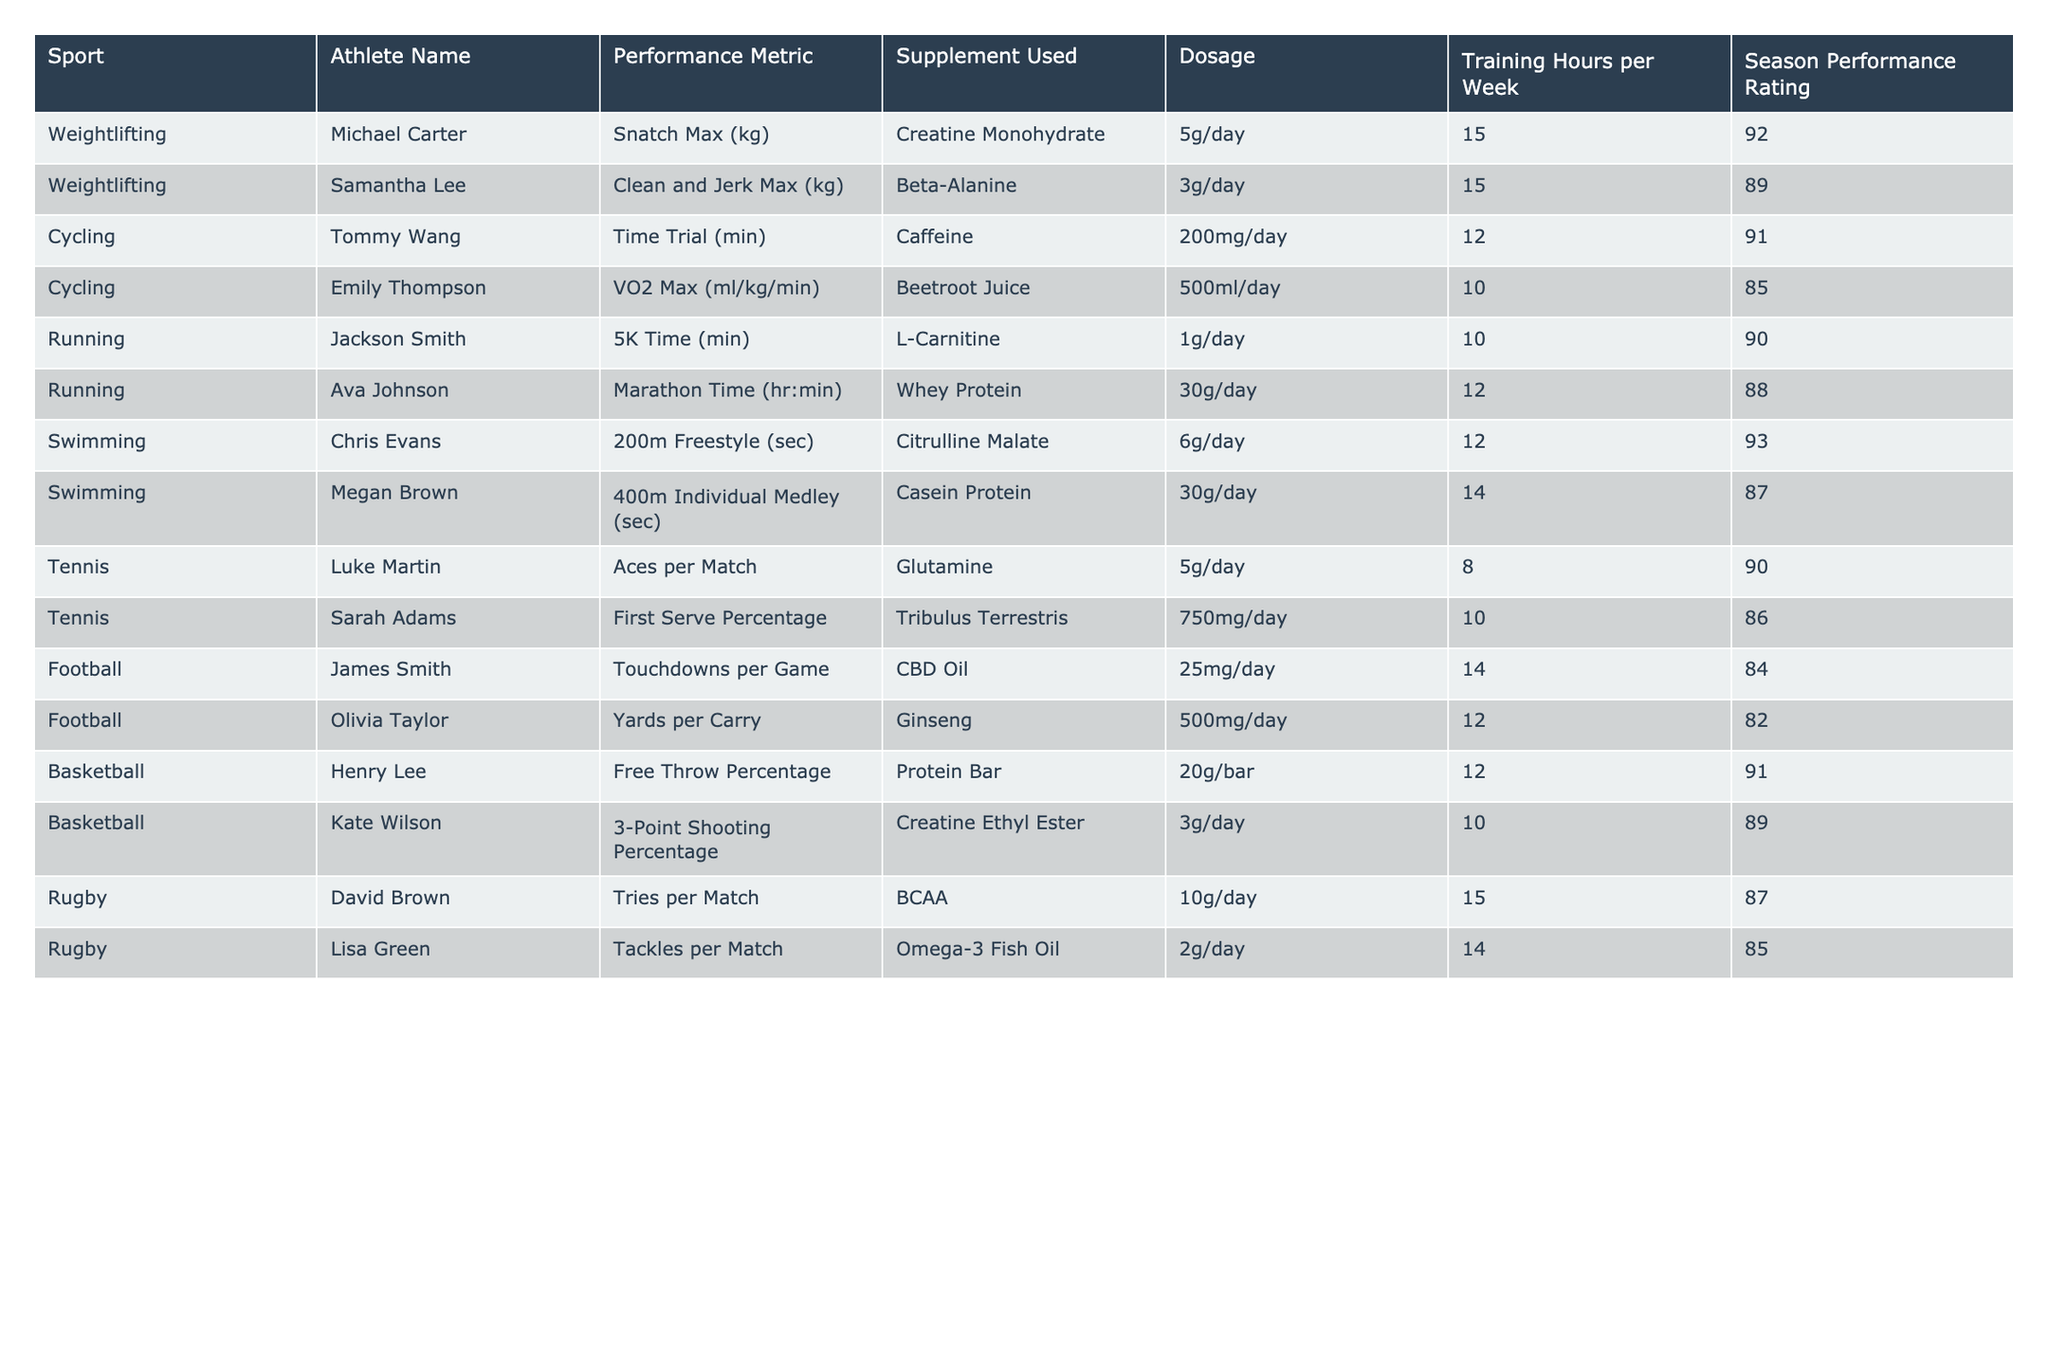What is the performance metric for Sarah Adams? According to the table, Sarah Adams has a performance metric of First Serve Percentage in Tennis.
Answer: First Serve Percentage Which athlete has the highest Season Performance Rating? By reviewing the Season Performance Ratings, Chris Evans has the highest rating of 93 in Swimming.
Answer: 93 What supplement is used by Jackson Smith? The table indicates that Jackson Smith uses L-Carnitine as his supplement.
Answer: L-Carnitine What is the average Training Hours per Week for athletes who use Creatine? The athletes using Creatine are Michael Carter (15 hours) and Kate Wilson (10 hours). Their total training hours sum to 25 hours, and with 2 athletes, the average is 25/2 = 12.5 hours.
Answer: 12.5 Is there an athlete who uses Omega-3 Fish Oil and has a performance rating above 85? Lisa Green uses Omega-3 Fish Oil and has a performance rating of 85, which is not above 85, so the answer is no.
Answer: No What is the difference in performance metric values between Samantha Lee and Ava Johnson? Samantha Lee's performance metric for Clean and Jerk Max is 89, while Ava Johnson's Marathon Time rating is 88. The difference is 89 - 88 = 1.
Answer: 1 Do all athletes who use protein supplements have a Season Performance Rating above 85? The athletes using protein supplements are Ava Johnson (88) and Megan Brown (87), both above 85. Thus, all athletes using protein supplements have ratings above 85.
Answer: Yes Which sport has the most athletes listed in the table and what are their names? Reviewing the table, Rugby has two athletes listed: David Brown and Lisa Green, while all other sports have one athlete each.
Answer: Rugby: David Brown, Lisa Green What is the correlation between dosage and performance rating for the cyclists? For cyclists, Tommy Wang uses 200mg/day and has a rating of 91, while Emily Thompson uses 500ml/day and has a rating of 85. The relationship shows that lower dosage corresponds to a higher rating, but only two points are insufficient for a strong conclusion.
Answer: Insufficient data for correlation Are weightlifters achieving higher performance metrics and what does this suggest? The performance metrics for weightlifters are specific to their lifts (Snatch Max, Clean and Jerk Max) and have ratings of 92 and 89. This suggests that the specific focus in training for these activities may lead to high performance metrics.
Answer: Suggests specialized training effectiveness 